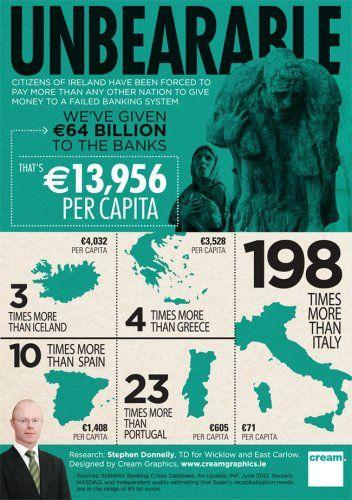Give some essential details in this illustration. The per capita income in Ireland is significantly higher than in Portugal, with a difference of €13,351. Iceland has a higher per capita income than Italy, with a difference of €3,961. Iceland has a higher per capita income than Greece, with €504 more given per capita in Iceland compared to Greece. The banks in Iceland receive an average of €4,032 per capita in monetary compensation. Iceland has a higher per capita income than Portugal, with a difference of €3,427. 